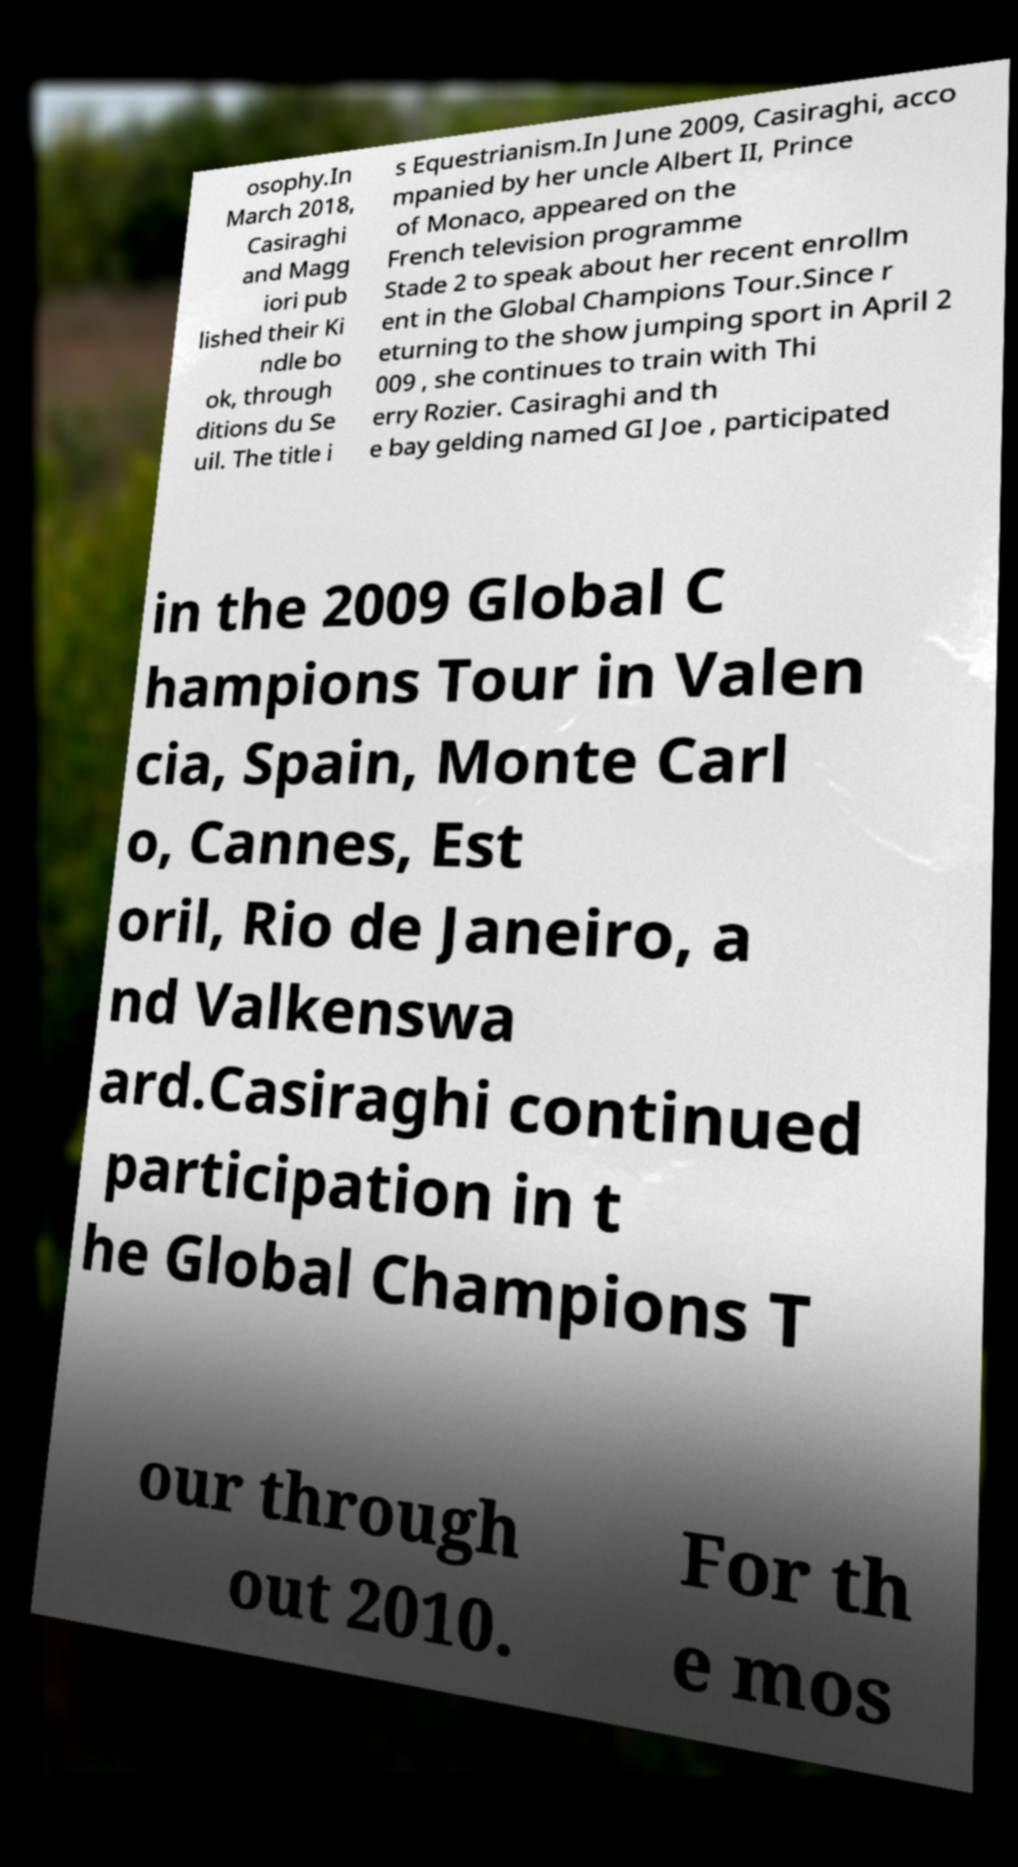Please read and relay the text visible in this image. What does it say? osophy.In March 2018, Casiraghi and Magg iori pub lished their Ki ndle bo ok, through ditions du Se uil. The title i s Equestrianism.In June 2009, Casiraghi, acco mpanied by her uncle Albert II, Prince of Monaco, appeared on the French television programme Stade 2 to speak about her recent enrollm ent in the Global Champions Tour.Since r eturning to the show jumping sport in April 2 009 , she continues to train with Thi erry Rozier. Casiraghi and th e bay gelding named GI Joe , participated in the 2009 Global C hampions Tour in Valen cia, Spain, Monte Carl o, Cannes, Est oril, Rio de Janeiro, a nd Valkenswa ard.Casiraghi continued participation in t he Global Champions T our through out 2010. For th e mos 